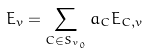<formula> <loc_0><loc_0><loc_500><loc_500>E _ { v } = \sum _ { C \in S _ { v _ { 0 } } } a _ { C } E _ { C , v }</formula> 